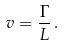Convert formula to latex. <formula><loc_0><loc_0><loc_500><loc_500>v = \frac { \Gamma } { L } \, .</formula> 